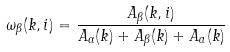Convert formula to latex. <formula><loc_0><loc_0><loc_500><loc_500>\omega _ { \beta } ( k , i ) = \frac { A _ { \beta } ( k , i ) } { A _ { \alpha } ( k ) + A _ { \beta } ( k ) + A _ { a } ( k ) }</formula> 